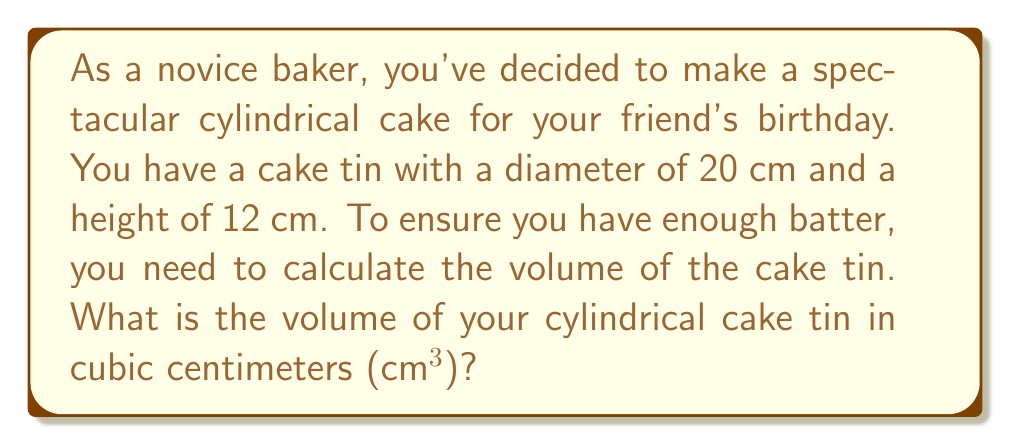Could you help me with this problem? To calculate the volume of a cylindrical cake tin, we need to use the formula for the volume of a cylinder:

$$V = \pi r^2 h$$

Where:
$V$ = volume
$\pi$ = pi (approximately 3.14159)
$r$ = radius of the base
$h$ = height of the cylinder

Let's break down the problem step-by-step:

1. Identify the given dimensions:
   - Diameter = 20 cm
   - Height = 12 cm

2. Calculate the radius:
   The radius is half the diameter.
   $r = \frac{20}{2} = 10$ cm

3. Apply the volume formula:
   $$V = \pi r^2 h$$
   $$V = \pi \cdot (10 \text{ cm})^2 \cdot 12 \text{ cm}$$

4. Simplify:
   $$V = \pi \cdot 100 \text{ cm}^2 \cdot 12 \text{ cm}$$
   $$V = 1200\pi \text{ cm}^3$$

5. Calculate the final result:
   $$V \approx 1200 \cdot 3.14159 \text{ cm}^3$$
   $$V \approx 3769.91 \text{ cm}^3$$

6. Round to the nearest whole number:
   $$V \approx 3770 \text{ cm}^3$$

This volume represents the amount of cake batter your tin can hold, which is essential for planning your recipe and ensuring you make enough batter for your spectacular birthday cake.
Answer: The volume of the cylindrical cake tin is approximately 3770 cm³. 